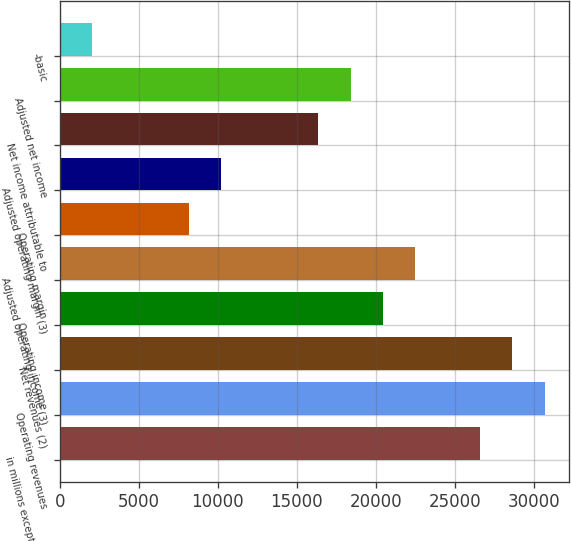Convert chart. <chart><loc_0><loc_0><loc_500><loc_500><bar_chart><fcel>in millions except per share<fcel>Operating revenues<fcel>Net revenues (2)<fcel>Operating income<fcel>Adjusted operating income (3)<fcel>Operating margin<fcel>Adjusted operating margin (3)<fcel>Net income attributable to<fcel>Adjusted net income<fcel>-basic<nl><fcel>26584.7<fcel>30674.5<fcel>28629.6<fcel>20450<fcel>22494.9<fcel>8180.57<fcel>10225.5<fcel>16360.2<fcel>18405.1<fcel>2045.87<nl></chart> 